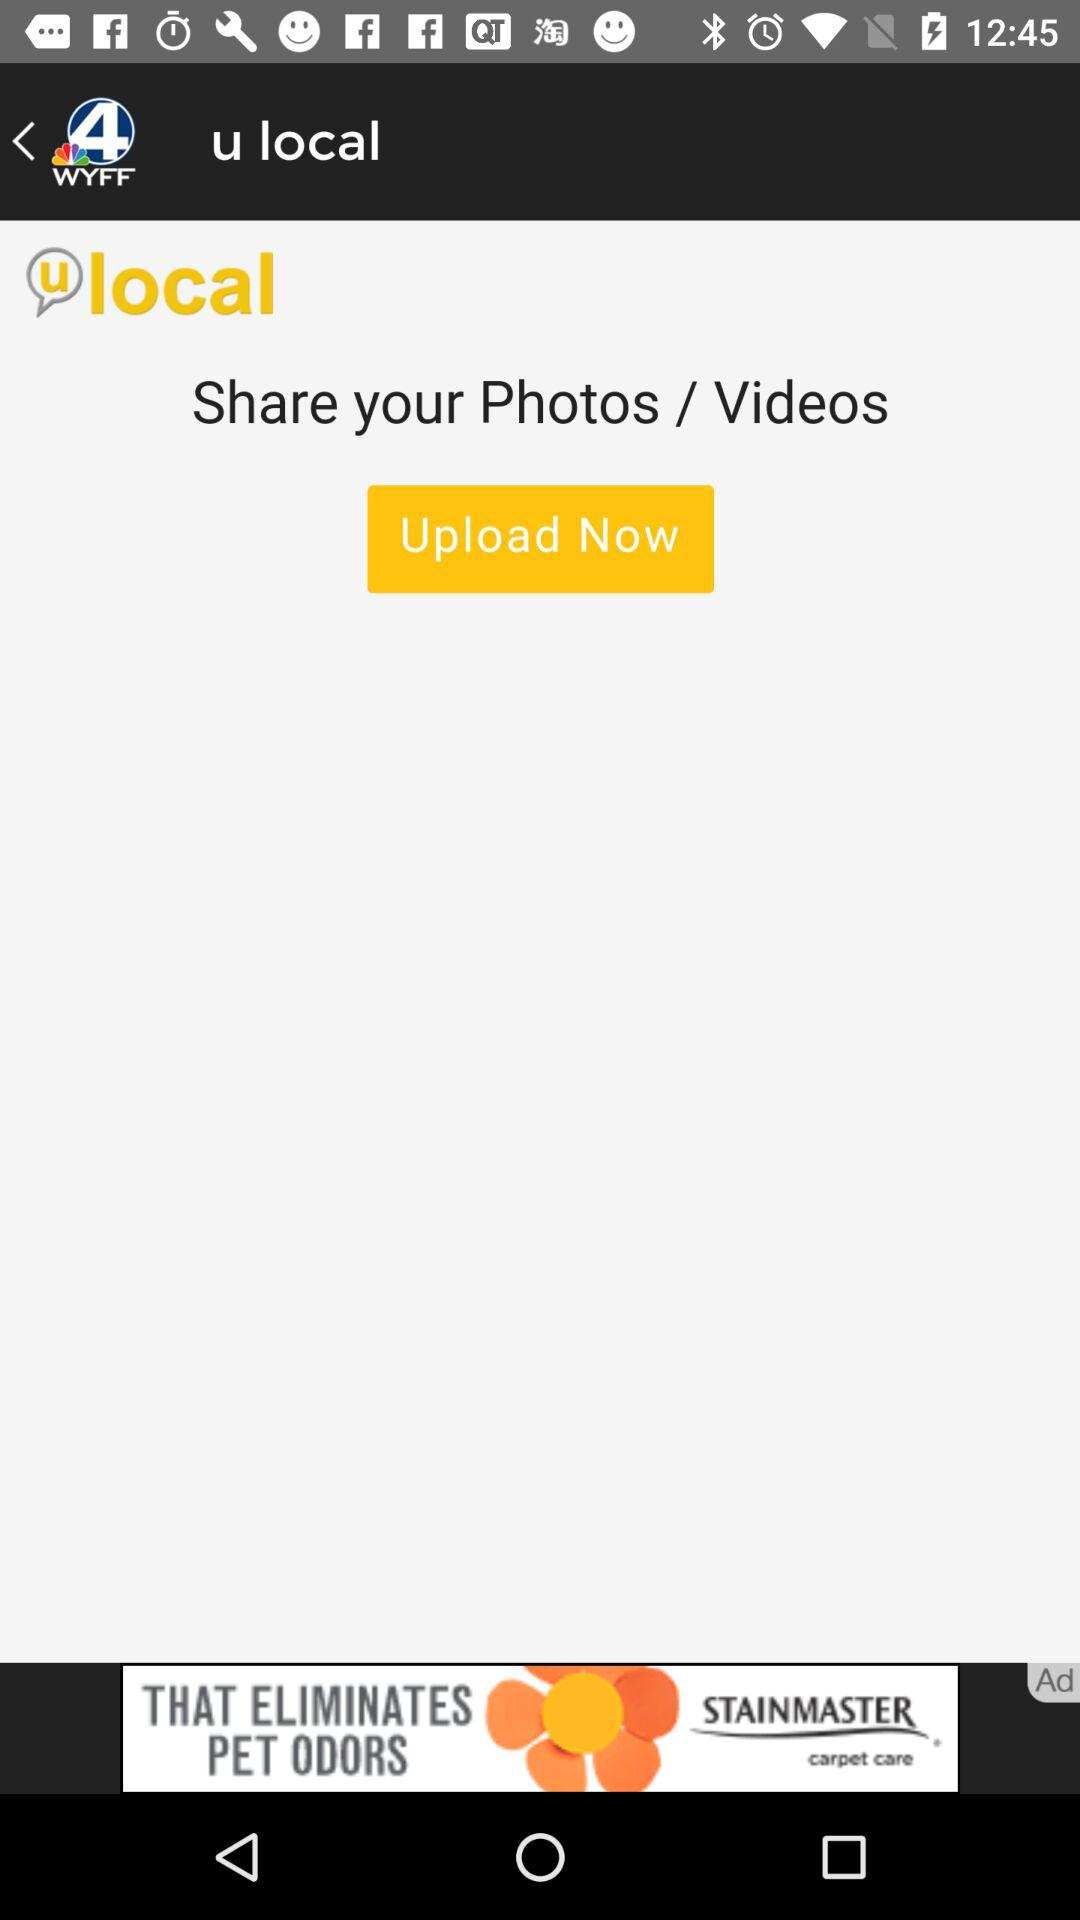What is the name of the application? The name of the application is "WYFF News 4 and weather". 